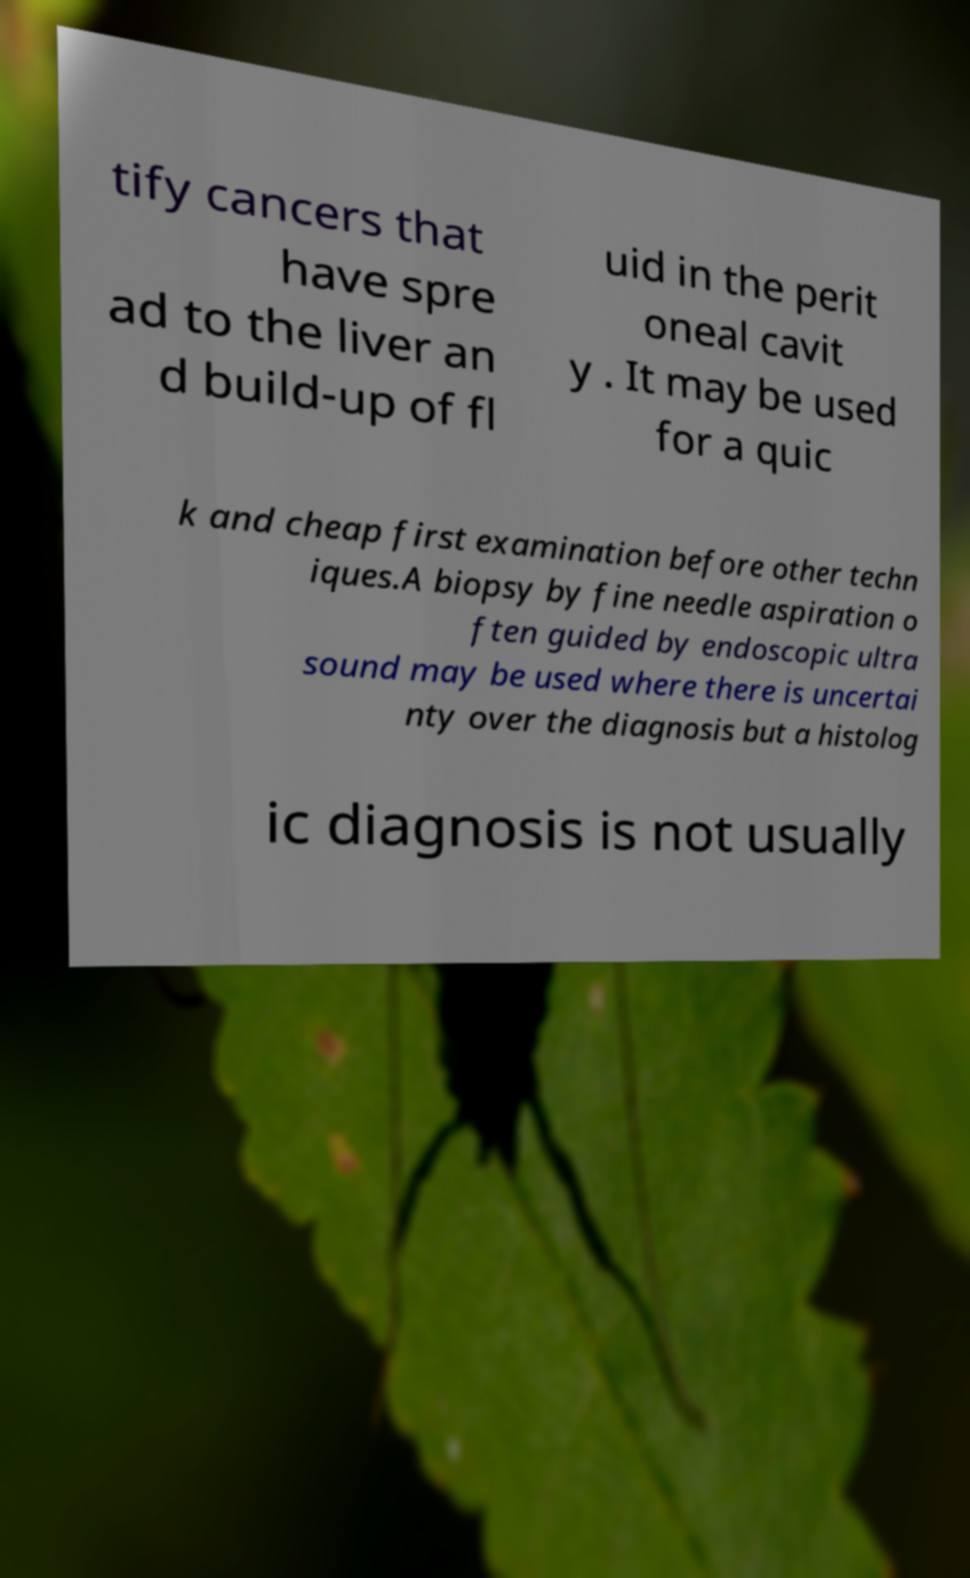There's text embedded in this image that I need extracted. Can you transcribe it verbatim? tify cancers that have spre ad to the liver an d build-up of fl uid in the perit oneal cavit y . It may be used for a quic k and cheap first examination before other techn iques.A biopsy by fine needle aspiration o ften guided by endoscopic ultra sound may be used where there is uncertai nty over the diagnosis but a histolog ic diagnosis is not usually 